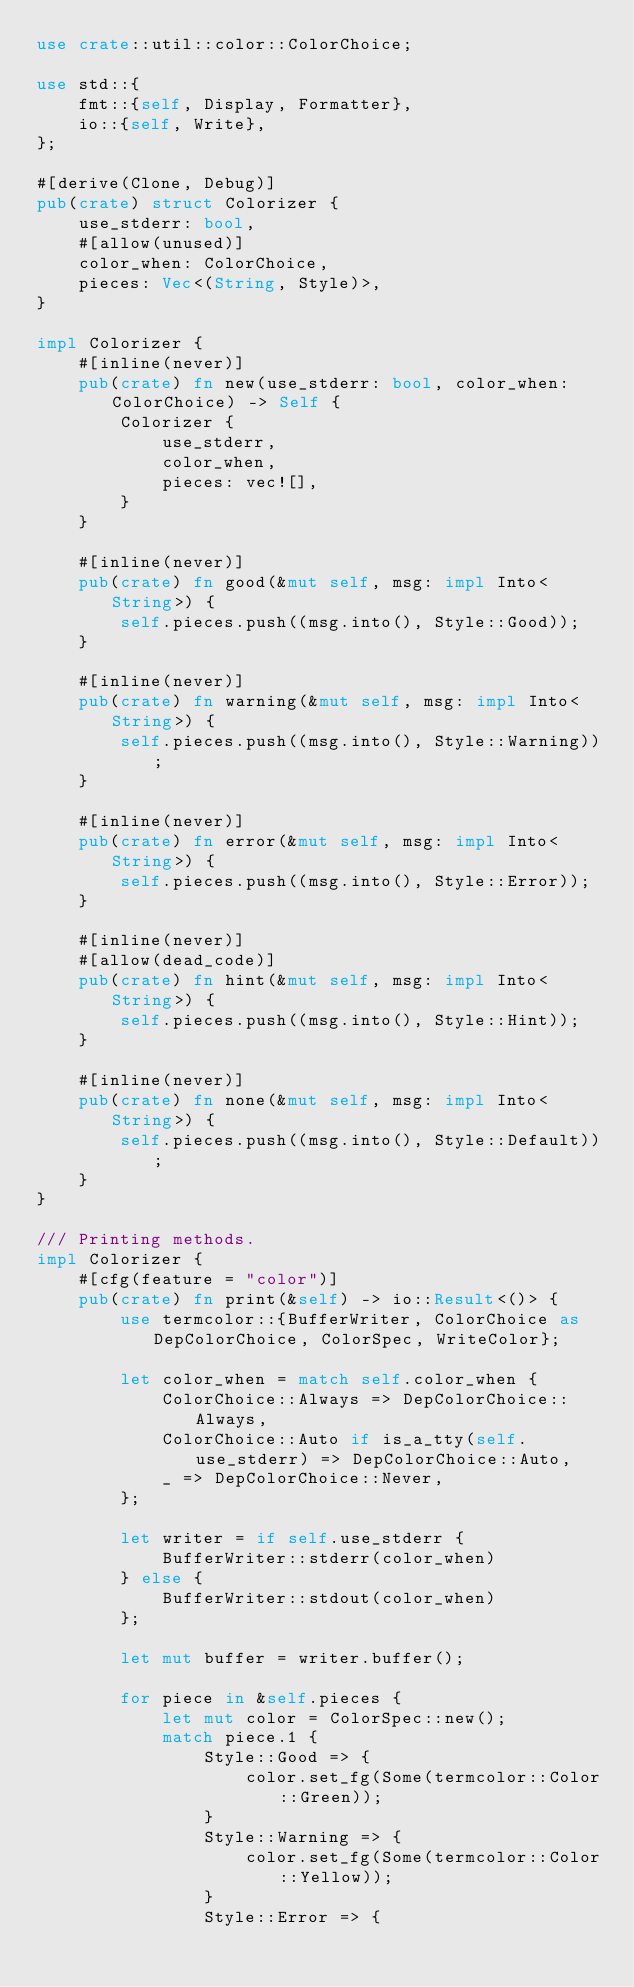Convert code to text. <code><loc_0><loc_0><loc_500><loc_500><_Rust_>use crate::util::color::ColorChoice;

use std::{
    fmt::{self, Display, Formatter},
    io::{self, Write},
};

#[derive(Clone, Debug)]
pub(crate) struct Colorizer {
    use_stderr: bool,
    #[allow(unused)]
    color_when: ColorChoice,
    pieces: Vec<(String, Style)>,
}

impl Colorizer {
    #[inline(never)]
    pub(crate) fn new(use_stderr: bool, color_when: ColorChoice) -> Self {
        Colorizer {
            use_stderr,
            color_when,
            pieces: vec![],
        }
    }

    #[inline(never)]
    pub(crate) fn good(&mut self, msg: impl Into<String>) {
        self.pieces.push((msg.into(), Style::Good));
    }

    #[inline(never)]
    pub(crate) fn warning(&mut self, msg: impl Into<String>) {
        self.pieces.push((msg.into(), Style::Warning));
    }

    #[inline(never)]
    pub(crate) fn error(&mut self, msg: impl Into<String>) {
        self.pieces.push((msg.into(), Style::Error));
    }

    #[inline(never)]
    #[allow(dead_code)]
    pub(crate) fn hint(&mut self, msg: impl Into<String>) {
        self.pieces.push((msg.into(), Style::Hint));
    }

    #[inline(never)]
    pub(crate) fn none(&mut self, msg: impl Into<String>) {
        self.pieces.push((msg.into(), Style::Default));
    }
}

/// Printing methods.
impl Colorizer {
    #[cfg(feature = "color")]
    pub(crate) fn print(&self) -> io::Result<()> {
        use termcolor::{BufferWriter, ColorChoice as DepColorChoice, ColorSpec, WriteColor};

        let color_when = match self.color_when {
            ColorChoice::Always => DepColorChoice::Always,
            ColorChoice::Auto if is_a_tty(self.use_stderr) => DepColorChoice::Auto,
            _ => DepColorChoice::Never,
        };

        let writer = if self.use_stderr {
            BufferWriter::stderr(color_when)
        } else {
            BufferWriter::stdout(color_when)
        };

        let mut buffer = writer.buffer();

        for piece in &self.pieces {
            let mut color = ColorSpec::new();
            match piece.1 {
                Style::Good => {
                    color.set_fg(Some(termcolor::Color::Green));
                }
                Style::Warning => {
                    color.set_fg(Some(termcolor::Color::Yellow));
                }
                Style::Error => {</code> 